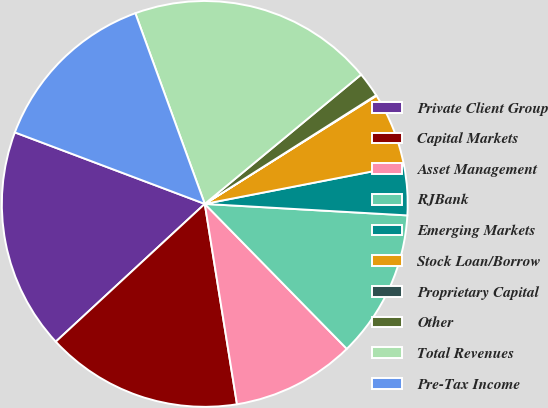Convert chart to OTSL. <chart><loc_0><loc_0><loc_500><loc_500><pie_chart><fcel>Private Client Group<fcel>Capital Markets<fcel>Asset Management<fcel>RJBank<fcel>Emerging Markets<fcel>Stock Loan/Borrow<fcel>Proprietary Capital<fcel>Other<fcel>Total Revenues<fcel>Pre-Tax Income<nl><fcel>17.61%<fcel>15.66%<fcel>9.8%<fcel>11.76%<fcel>3.95%<fcel>5.9%<fcel>0.05%<fcel>2.0%<fcel>19.56%<fcel>13.71%<nl></chart> 